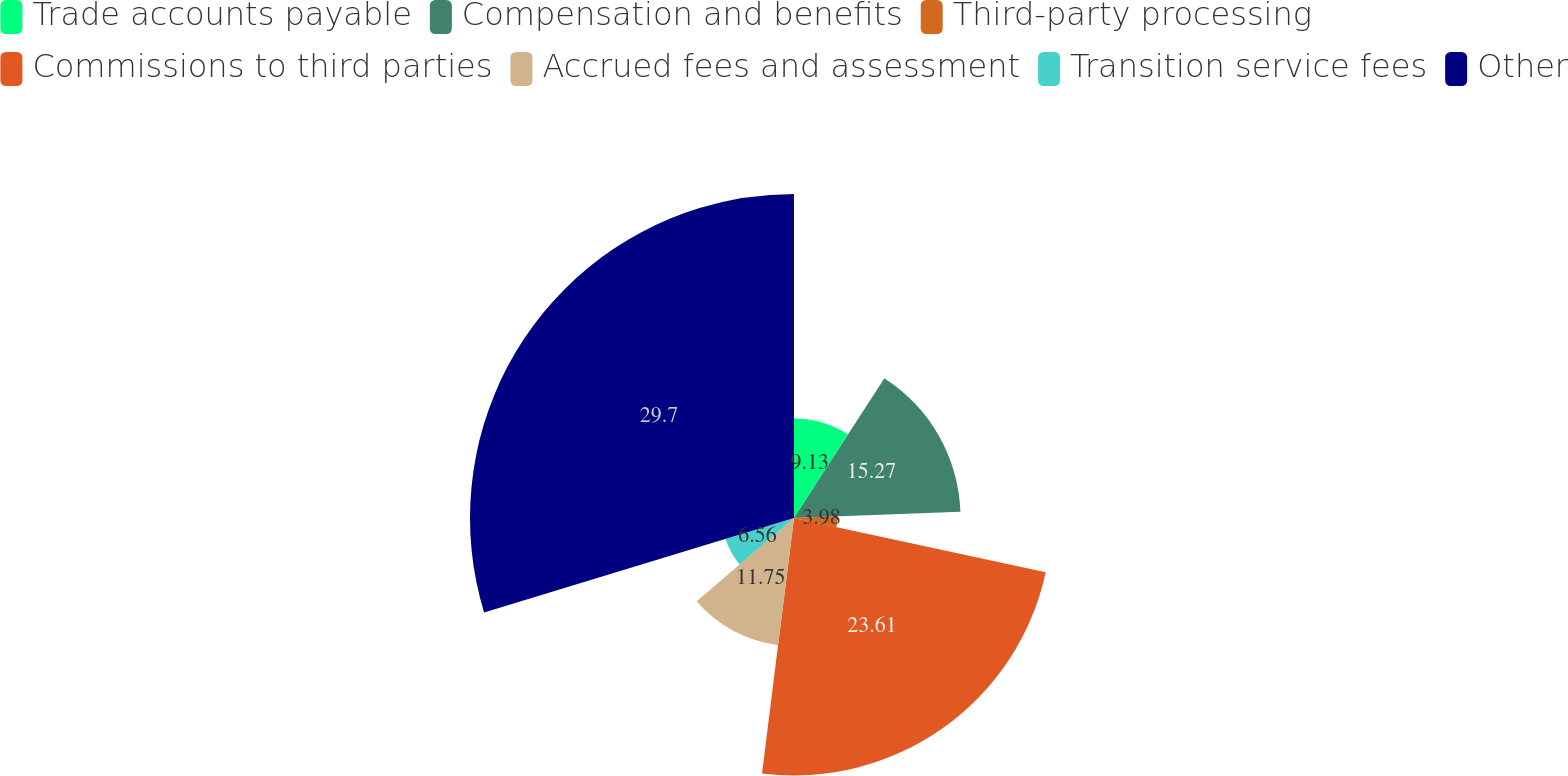Convert chart to OTSL. <chart><loc_0><loc_0><loc_500><loc_500><pie_chart><fcel>Trade accounts payable<fcel>Compensation and benefits<fcel>Third-party processing<fcel>Commissions to third parties<fcel>Accrued fees and assessment<fcel>Transition service fees<fcel>Other<nl><fcel>9.13%<fcel>15.27%<fcel>3.98%<fcel>23.61%<fcel>11.75%<fcel>6.56%<fcel>29.71%<nl></chart> 